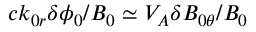Convert formula to latex. <formula><loc_0><loc_0><loc_500><loc_500>c k _ { 0 r } \delta \phi _ { 0 } / B _ { 0 } \simeq V _ { A } \delta B _ { 0 \theta } / B _ { 0 }</formula> 